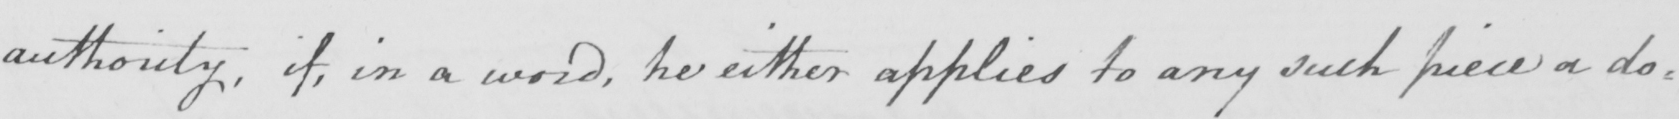Please transcribe the handwritten text in this image. authority , if , in a word , he either applies to any such piece a do= 